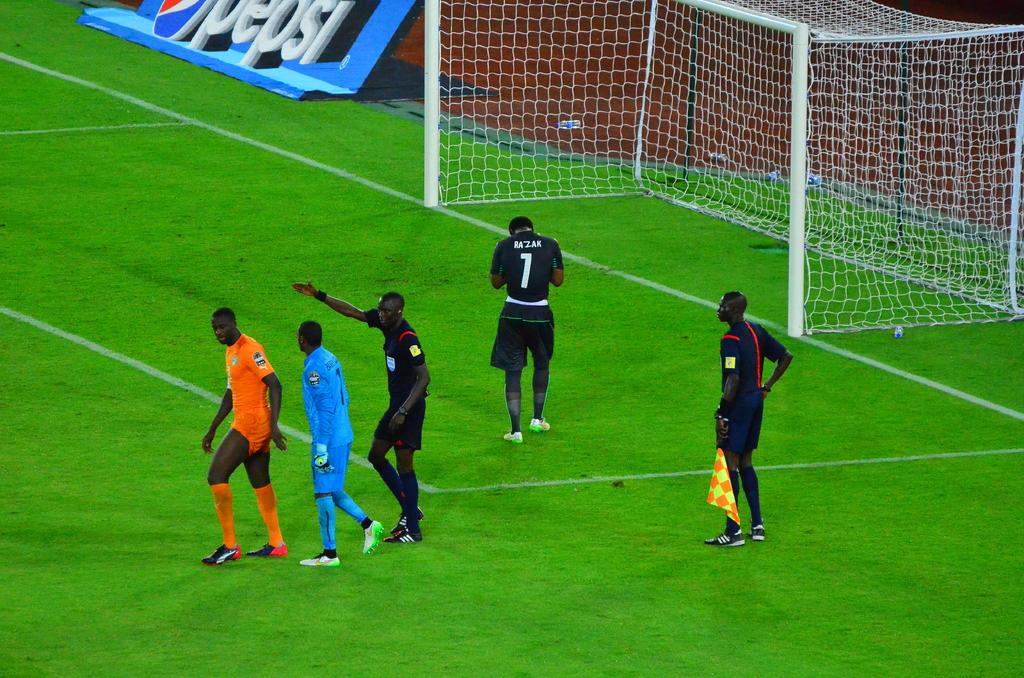<image>
Give a short and clear explanation of the subsequent image. Soccer players including number 1 on a soccer field. 